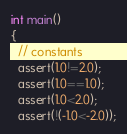Convert code to text. <code><loc_0><loc_0><loc_500><loc_500><_C_>int main()
{
  // constants
  assert(1.0!=2.0);
  assert(1.0==1.0);
  assert(1.0<2.0);
  assert(!(-1.0<-2.0));</code> 